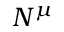<formula> <loc_0><loc_0><loc_500><loc_500>N ^ { \mu }</formula> 